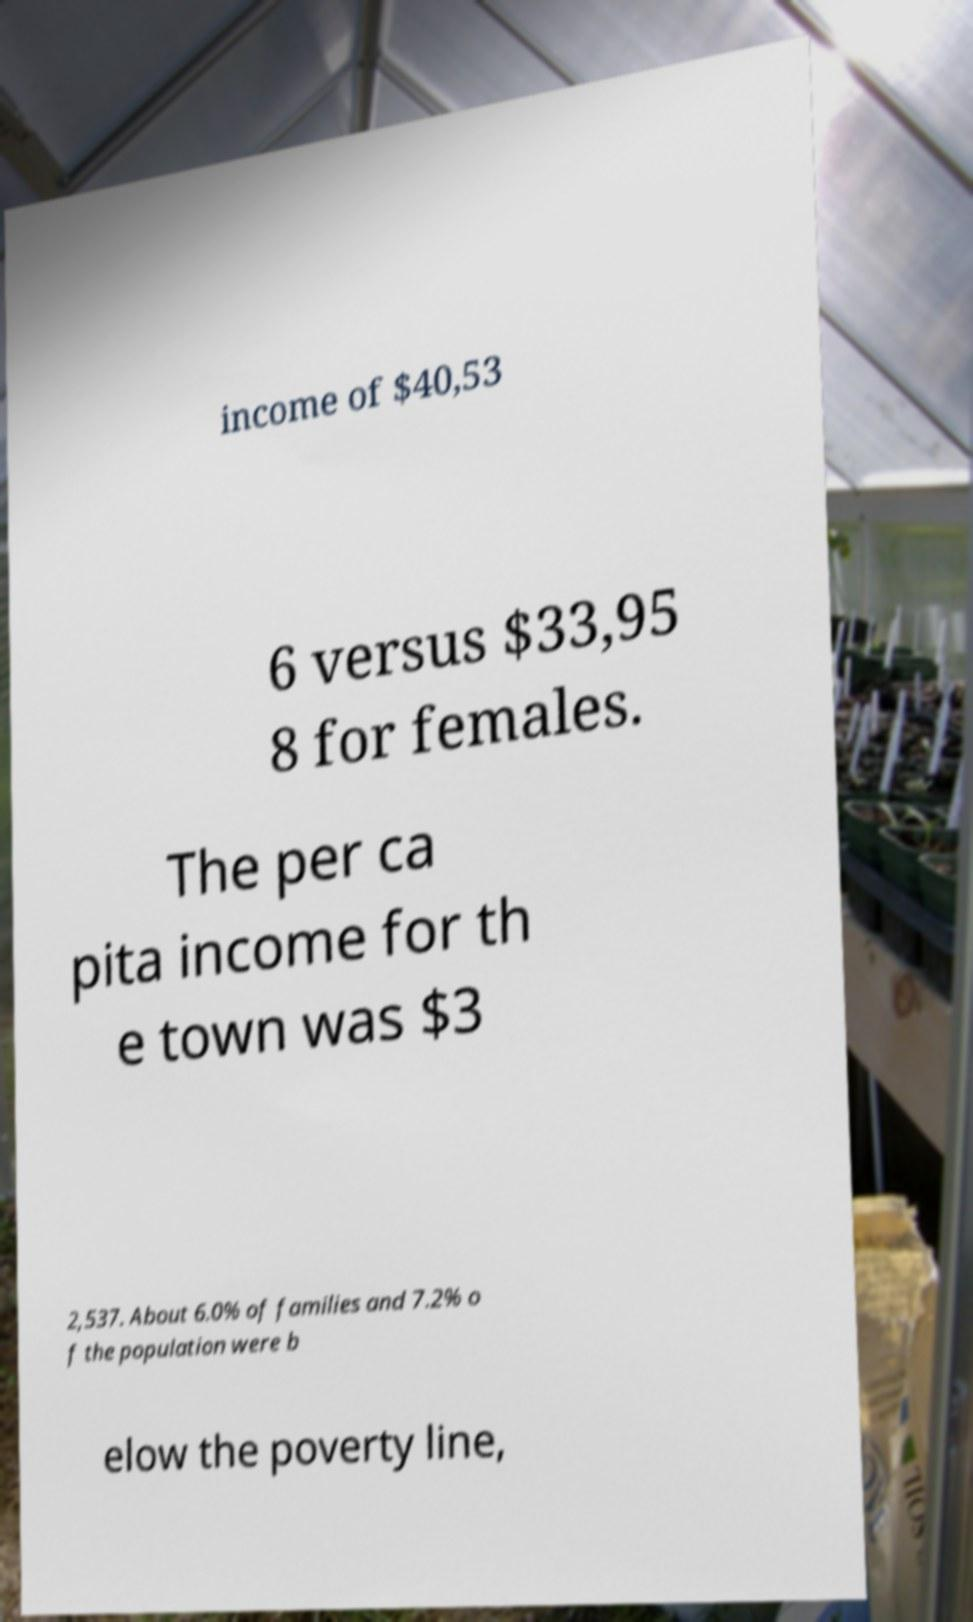What messages or text are displayed in this image? I need them in a readable, typed format. income of $40,53 6 versus $33,95 8 for females. The per ca pita income for th e town was $3 2,537. About 6.0% of families and 7.2% o f the population were b elow the poverty line, 